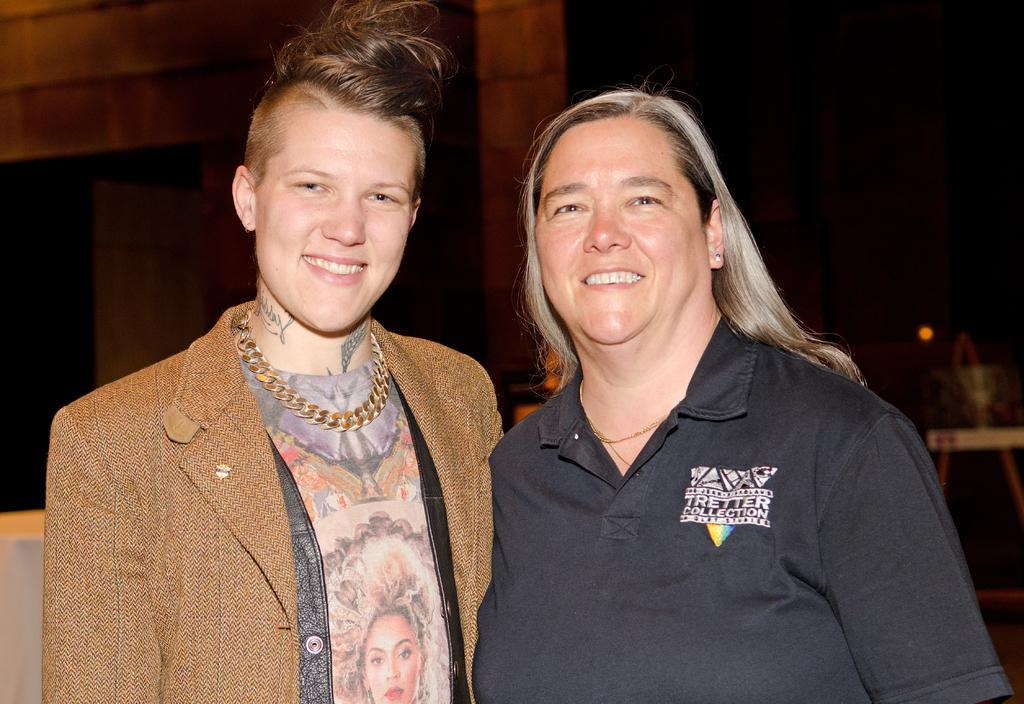How many people are in the image? There are a few people in the image. What can be seen in the background of the image? There is a wall in the background of the image. What is located on the right side of the image? There is an object on the right side of the image. What color is the object on the left side of the image? There is a white-colored object on the left side of the image. Can you hear the insects laughing in the image? There are no insects or sounds of laughter present in the image. 